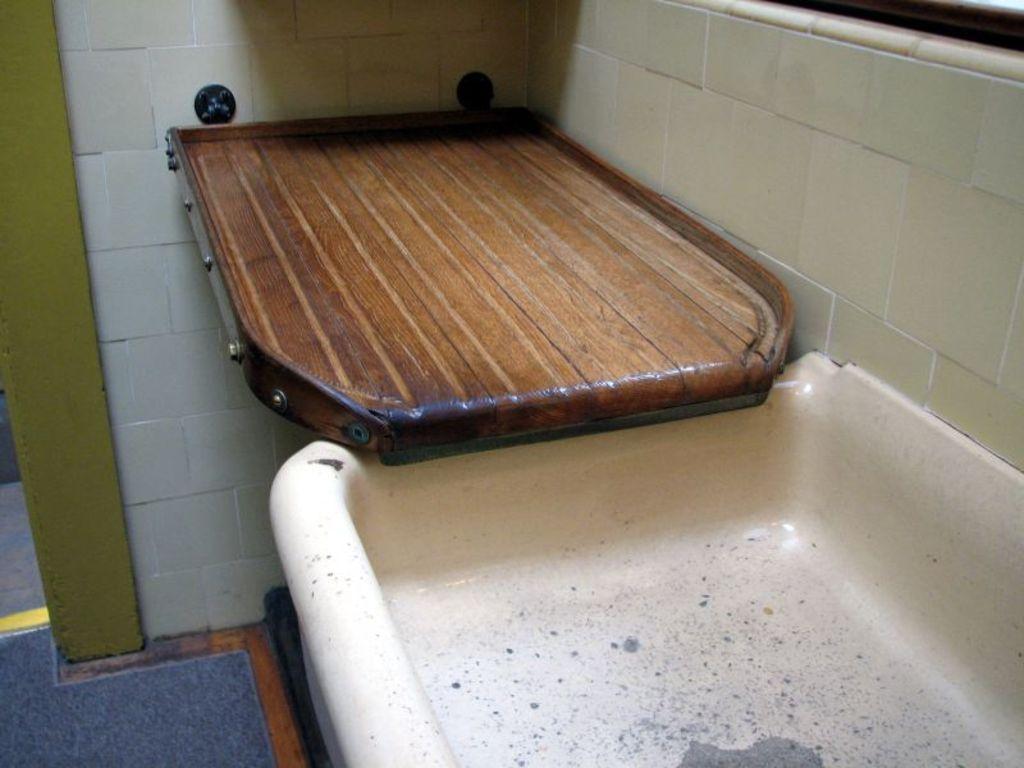Describe this image in one or two sentences. In this image in the center it looks like a wash basin and some wooden board, in the background there is wall. 